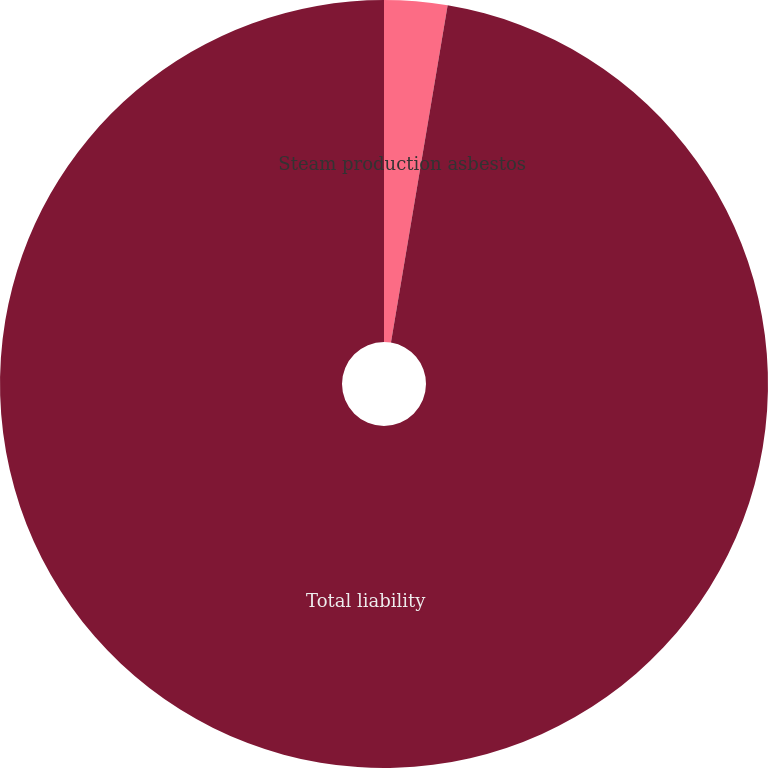<chart> <loc_0><loc_0><loc_500><loc_500><pie_chart><fcel>Steam production asbestos<fcel>Total liability<nl><fcel>2.65%<fcel>97.35%<nl></chart> 